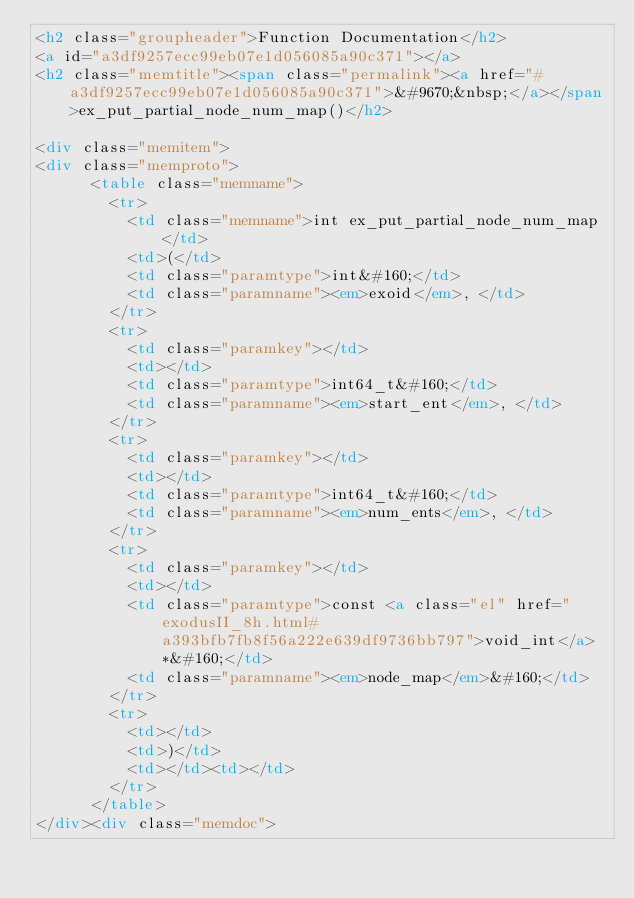<code> <loc_0><loc_0><loc_500><loc_500><_HTML_><h2 class="groupheader">Function Documentation</h2>
<a id="a3df9257ecc99eb07e1d056085a90c371"></a>
<h2 class="memtitle"><span class="permalink"><a href="#a3df9257ecc99eb07e1d056085a90c371">&#9670;&nbsp;</a></span>ex_put_partial_node_num_map()</h2>

<div class="memitem">
<div class="memproto">
      <table class="memname">
        <tr>
          <td class="memname">int ex_put_partial_node_num_map </td>
          <td>(</td>
          <td class="paramtype">int&#160;</td>
          <td class="paramname"><em>exoid</em>, </td>
        </tr>
        <tr>
          <td class="paramkey"></td>
          <td></td>
          <td class="paramtype">int64_t&#160;</td>
          <td class="paramname"><em>start_ent</em>, </td>
        </tr>
        <tr>
          <td class="paramkey"></td>
          <td></td>
          <td class="paramtype">int64_t&#160;</td>
          <td class="paramname"><em>num_ents</em>, </td>
        </tr>
        <tr>
          <td class="paramkey"></td>
          <td></td>
          <td class="paramtype">const <a class="el" href="exodusII_8h.html#a393bfb7fb8f56a222e639df9736bb797">void_int</a> *&#160;</td>
          <td class="paramname"><em>node_map</em>&#160;</td>
        </tr>
        <tr>
          <td></td>
          <td>)</td>
          <td></td><td></td>
        </tr>
      </table>
</div><div class="memdoc"></code> 